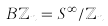<formula> <loc_0><loc_0><loc_500><loc_500>B \mathbb { Z } _ { n } = S ^ { \infty } / \mathbb { Z } _ { n }</formula> 